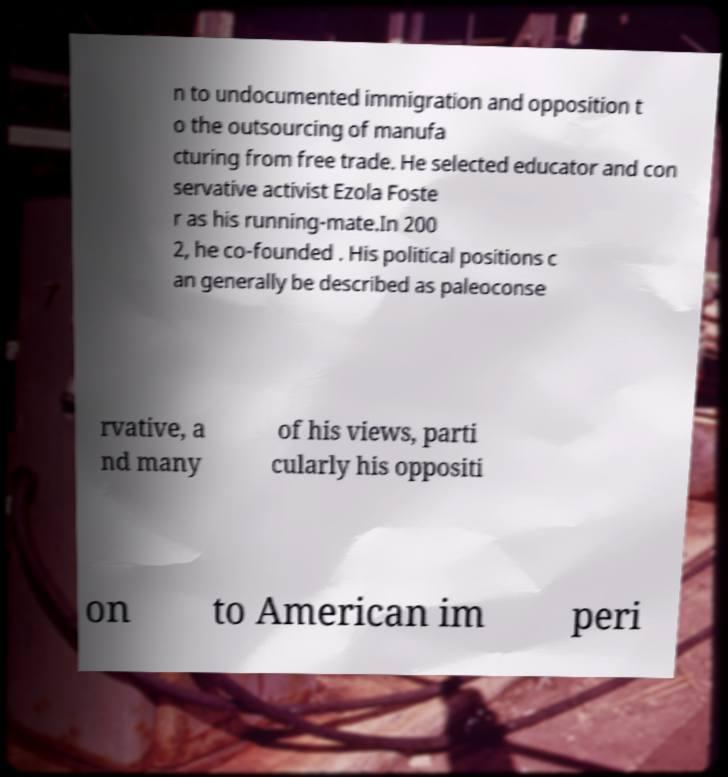I need the written content from this picture converted into text. Can you do that? n to undocumented immigration and opposition t o the outsourcing of manufa cturing from free trade. He selected educator and con servative activist Ezola Foste r as his running-mate.In 200 2, he co-founded . His political positions c an generally be described as paleoconse rvative, a nd many of his views, parti cularly his oppositi on to American im peri 